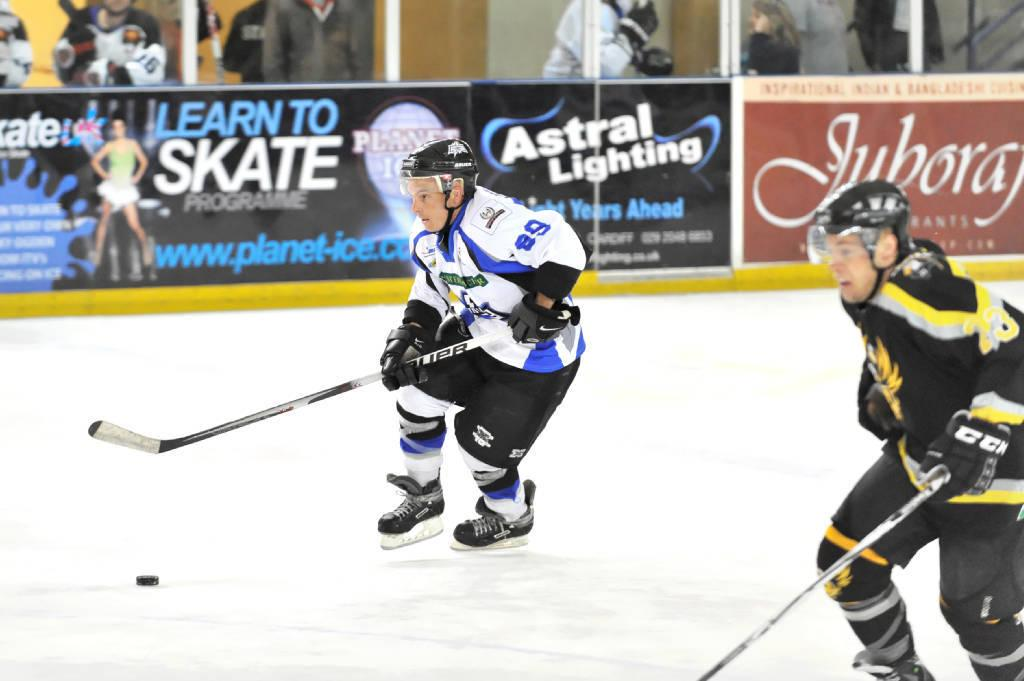How many people are in the image? There are two persons in the image. What protective gear are the persons wearing? Both persons are wearing helmets, gloves, and shoes. What objects are the persons holding? Both persons are holding bats. What is the setting of the image? The scene takes place on snow. What can be seen in the background of the image? There are banners and other persons in the background. What is the opinion of the snow in the image? The snow in the image does not have an opinion, as it is an inanimate object. Can you touch the trail in the image? There is no trail present in the image, so it cannot be touched. 